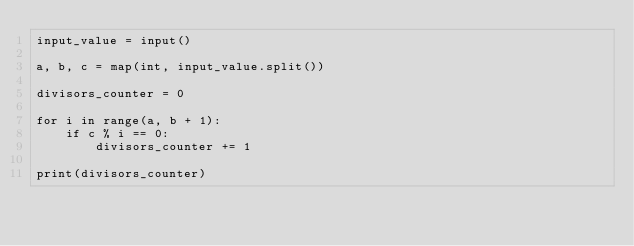<code> <loc_0><loc_0><loc_500><loc_500><_Python_>input_value = input()

a, b, c = map(int, input_value.split())

divisors_counter = 0

for i in range(a, b + 1):
    if c % i == 0:
        divisors_counter += 1

print(divisors_counter)
</code> 